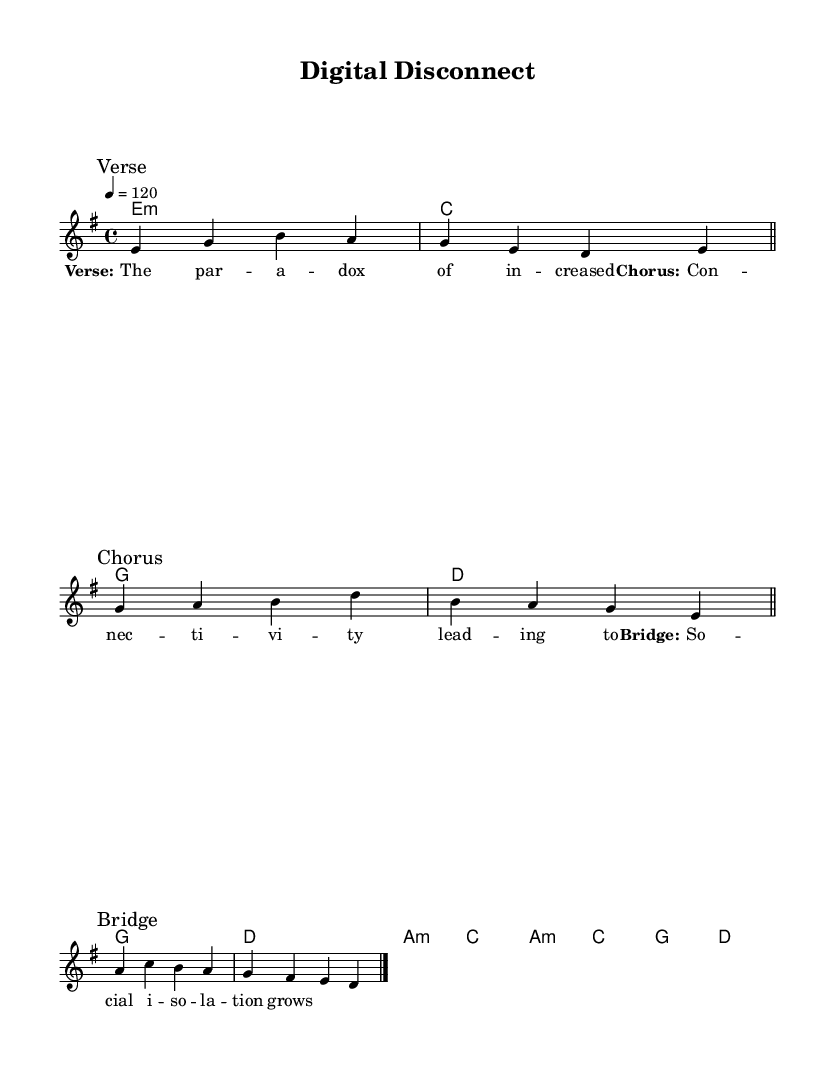What is the key signature of this music? The key signature is E minor, which has one sharp (F#) indicated on the staff.
Answer: E minor What is the time signature of this music? The time signature is 4/4, as shown at the beginning of the score. This means there are four beats in each measure.
Answer: 4/4 What is the tempo of the piece? The tempo marking indicates a speed of 120 beats per minute, which is noted in the tempo instruction at the start of the score.
Answer: 120 How many sections are there in this piece? The piece contains three distinct sections labeled as Verse, Chorus, and Bridge, making a total of three sections.
Answer: Three What are the primary chords used in the chorus? The primary chords used in the chorus are G, D, A minor, and C, as indicated in the chord progression during that section.
Answer: G, D, A minor, C Which chord is used at the start of the verse? The chord at the start of the verse is E minor, as shown in the chord mode notation before the melody begins.
Answer: E minor What lyrical theme is suggested in the bridge? The bridge lyrically suggests the theme of social isolation, as indicated in the lyrics provided for that section of the music.
Answer: Social isolation 